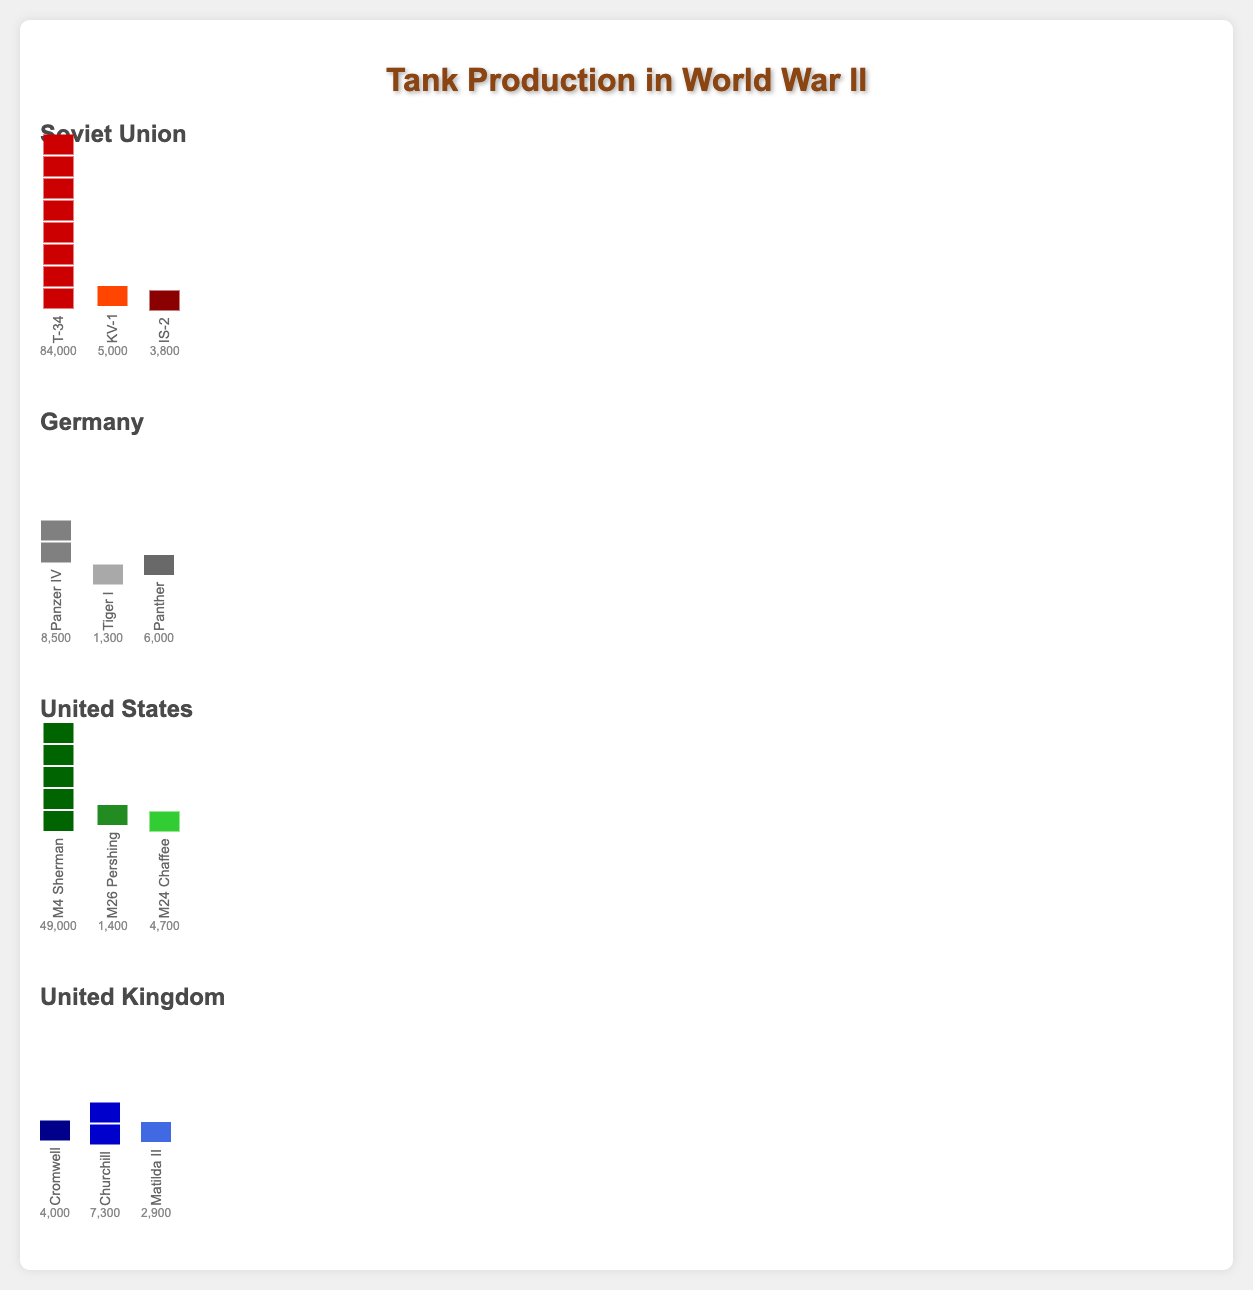Which country produced the most tanks? By summing the quantities of all types of tanks for each country and comparing them, we find that the Soviet Union has the highest total: T-34 (84,000) + KV-1 (5,000) + IS-2 (3,800) = 92,800 units.
Answer: Soviet Union How many more T-34 tanks were produced than Panzer IV tanks? Compare the quantities of T-34 (84,000) and Panzer IV (8,500) by subtracting the smaller number from the larger one: 84,000 - 8,500 = 75,500.
Answer: 75,500 Which tank model had the highest production in the United Kingdom? Among the tank models Cromwell, Churchill, and Matilda II, the Churchill has the highest production at 7,300 units.
Answer: Churchill How does the number of M4 Sherman tanks compare to the total production of tanks in Germany? The number of M4 Sherman tanks is 49,000. The total production of tanks in Germany is the sum of Panzer IV (8,500), Tiger I (1,300), and Panther (6,000), which is 15,800. Compare 49,000 and 15,800: 49,000 > 15,800.
Answer: M4 Sherman production is higher What is the combined production of the IS-2 and KV-1 tanks from the Soviet Union? Sum the production quantities of IS-2 (3,800) and KV-1 (5,000): 3,800 + 5,000 = 8,800.
Answer: 8,800 Which tank type had the lowest production number in Germany? Compare the production numbers of Panzer IV (8,500), Tiger I (1,300), and Panther (6,000). The lowest is Tiger I with 1,300 units.
Answer: Tiger I Between the Soviet Union and the United States, which country had a higher production of its most-produced tank? The most-produced tank in the Soviet Union is T-34 (84,000) and in the United States is M4 Sherman (49,000). Compare 84,000 and 49,000: the Soviet Union produced more.
Answer: Soviet Union What is the total number of tanks produced by the United Kingdom? Add the quantities of Cromwell (4,000), Churchill (7,300), and Matilda II (2,900): 4,000 + 7,300 + 2,900 = 14,200.
Answer: 14,200 